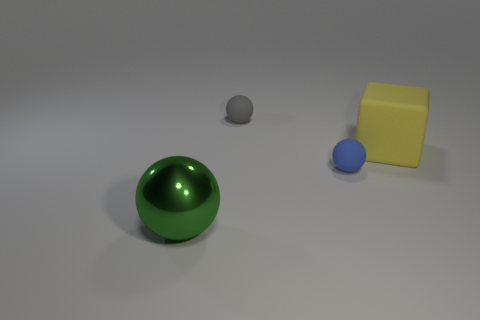What is the size of the blue rubber object that is the same shape as the gray matte object?
Offer a terse response. Small. What color is the large metallic object that is the same shape as the blue matte object?
Offer a very short reply. Green. There is a rubber ball behind the large cube; is it the same size as the object to the left of the small gray ball?
Ensure brevity in your answer.  No. Is the size of the gray matte thing the same as the green ball that is left of the yellow rubber cube?
Your answer should be compact. No. What size is the green metallic ball?
Keep it short and to the point. Large. What number of objects are either big cubes or balls that are to the right of the green ball?
Give a very brief answer. 3. Is the big thing on the right side of the big green object made of the same material as the small gray ball?
Offer a very short reply. Yes. There is a matte thing that is the same size as the gray ball; what is its color?
Ensure brevity in your answer.  Blue. Is there another small object that has the same shape as the green shiny thing?
Your answer should be very brief. Yes. There is a matte sphere on the right side of the object that is behind the big thing that is behind the big metallic thing; what is its color?
Offer a terse response. Blue. 